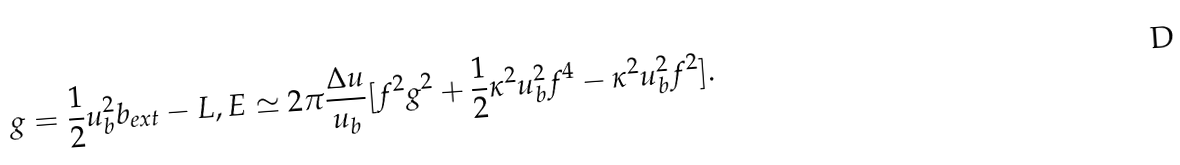Convert formula to latex. <formula><loc_0><loc_0><loc_500><loc_500>g = \frac { 1 } { 2 } u _ { b } ^ { 2 } b _ { e x t } - L , E \simeq 2 \pi \frac { \Delta u } { u _ { b } } [ f ^ { 2 } g ^ { 2 } + \frac { 1 } { 2 } \kappa ^ { 2 } u _ { b } ^ { 2 } f ^ { 4 } - \kappa ^ { 2 } u _ { b } ^ { 2 } f ^ { 2 } ] .</formula> 